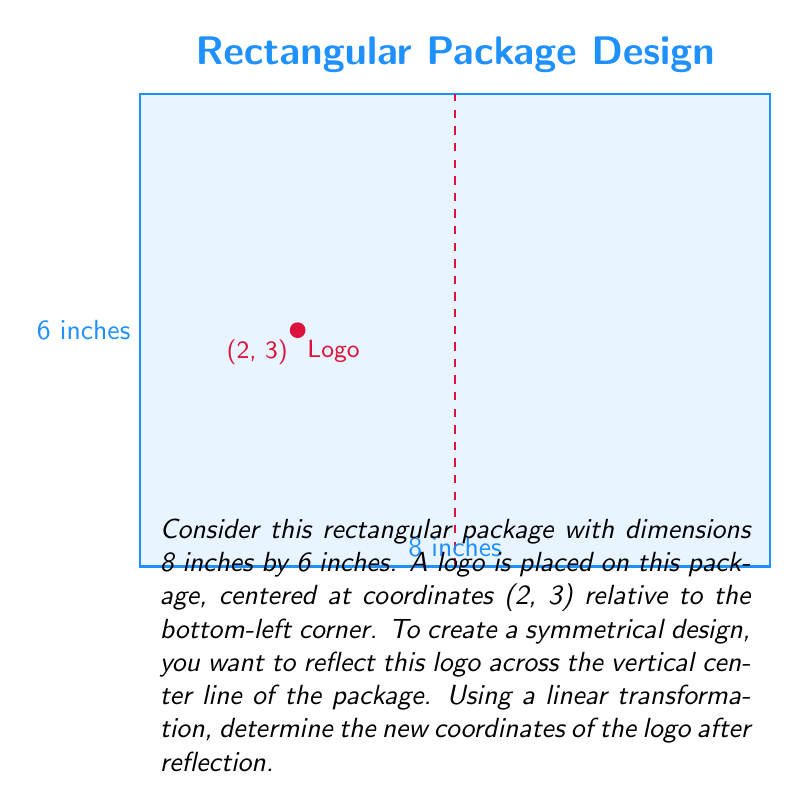Provide a solution to this math problem. Let's approach this step-by-step:

1) First, we need to identify the equation of the vertical center line. The package is 8 inches wide, so the center line is at x = 4.

2) The reflection across a vertical line x = a can be represented by the linear transformation:

   $$ T(x, y) = (2a - x, y) $$

   In our case, a = 4, so our transformation becomes:

   $$ T(x, y) = (8 - x, y) $$

3) Now, we apply this transformation to the original coordinates of the logo (2, 3):

   $$ T(2, 3) = (8 - 2, 3) = (6, 3) $$

4) To verify, let's check the distance from the new point to the right edge:
   - The package is 8 inches wide
   - The new x-coordinate is 6
   - Distance from right edge = 8 - 6 = 2 inches

   This matches the original distance from the left edge, confirming symmetry.

5) Therefore, the new coordinates of the logo after reflection are (6, 3).
Answer: (6, 3) 